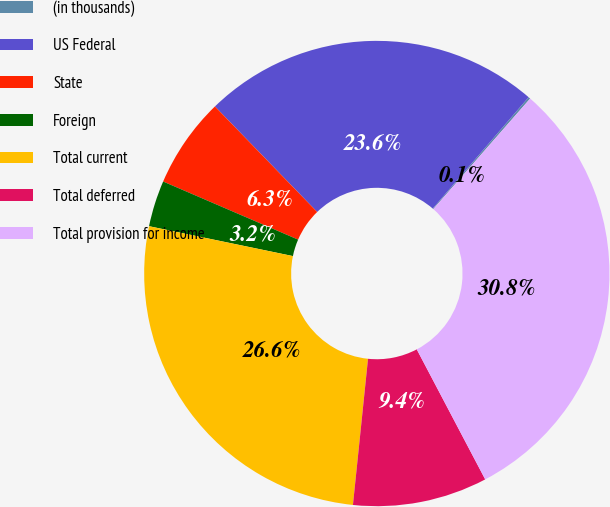<chart> <loc_0><loc_0><loc_500><loc_500><pie_chart><fcel>(in thousands)<fcel>US Federal<fcel>State<fcel>Foreign<fcel>Total current<fcel>Total deferred<fcel>Total provision for income<nl><fcel>0.14%<fcel>23.56%<fcel>6.28%<fcel>3.21%<fcel>26.62%<fcel>9.35%<fcel>30.83%<nl></chart> 